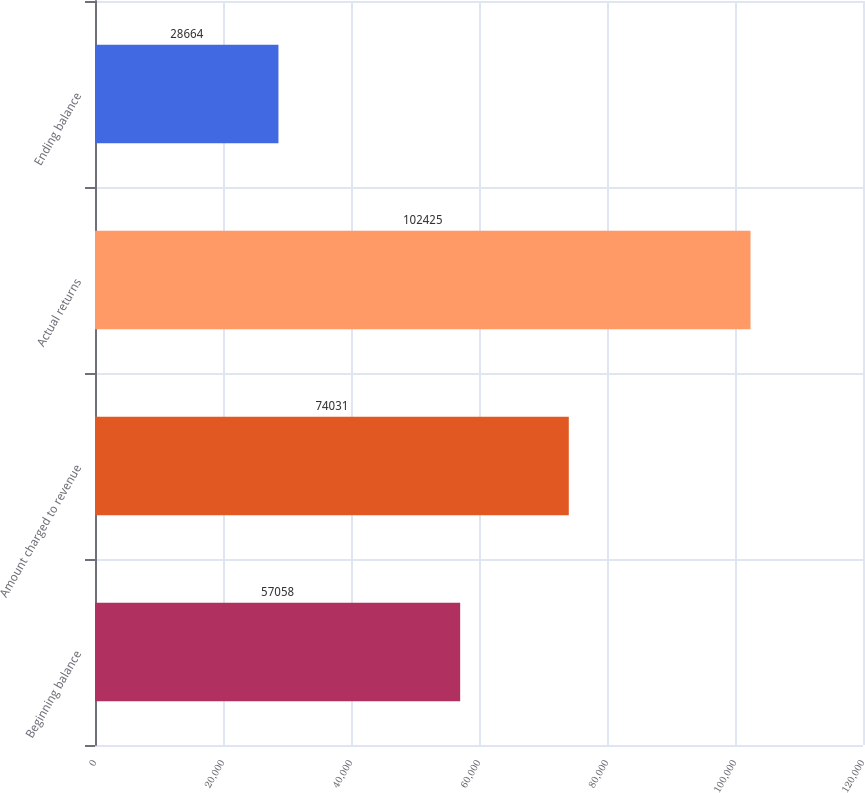<chart> <loc_0><loc_0><loc_500><loc_500><bar_chart><fcel>Beginning balance<fcel>Amount charged to revenue<fcel>Actual returns<fcel>Ending balance<nl><fcel>57058<fcel>74031<fcel>102425<fcel>28664<nl></chart> 